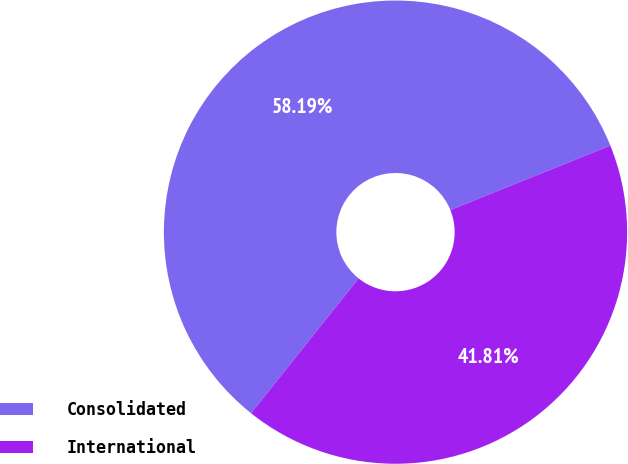Convert chart to OTSL. <chart><loc_0><loc_0><loc_500><loc_500><pie_chart><fcel>Consolidated<fcel>International<nl><fcel>58.19%<fcel>41.81%<nl></chart> 